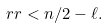<formula> <loc_0><loc_0><loc_500><loc_500>\ r r < n / 2 - \ell .</formula> 